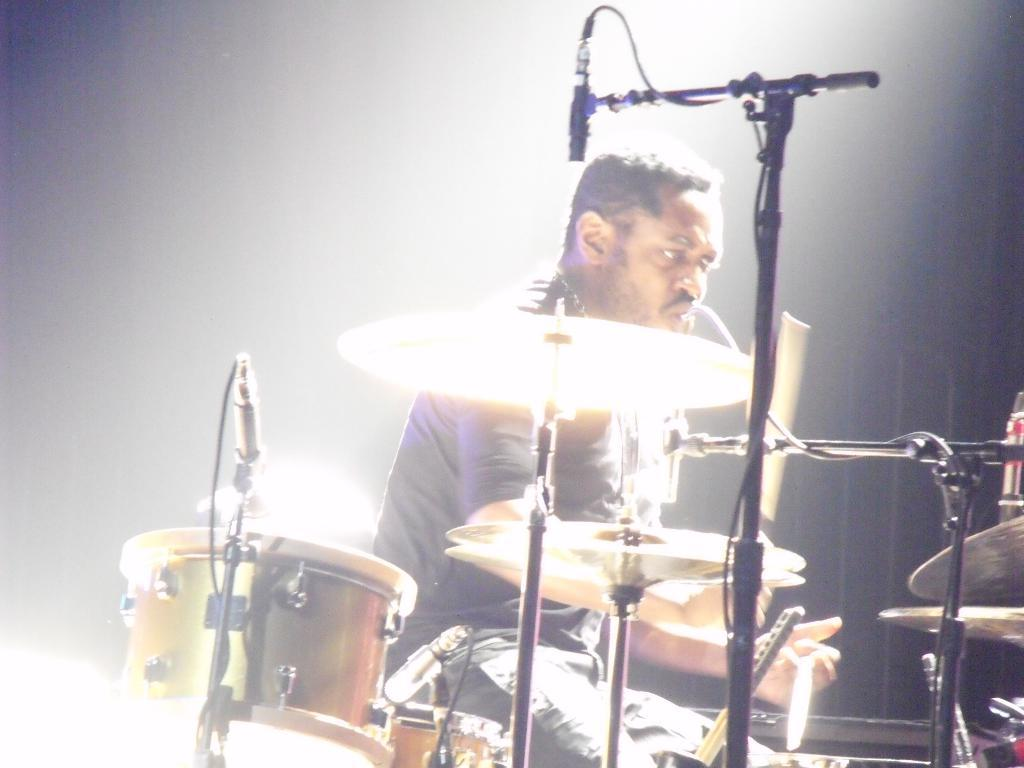What is the main subject of the image? There is a person in the image. What is the person doing in the image? The person is playing drums. Can you describe the lighting in the image? There is a white color light on the bottom left side of the image. How many tents are visible in the image? There are no tents present in the image. What type of twist can be seen in the person's hair in the image? The person's hair is not visible in the image, so it is not possible to determine if there is any twist. 